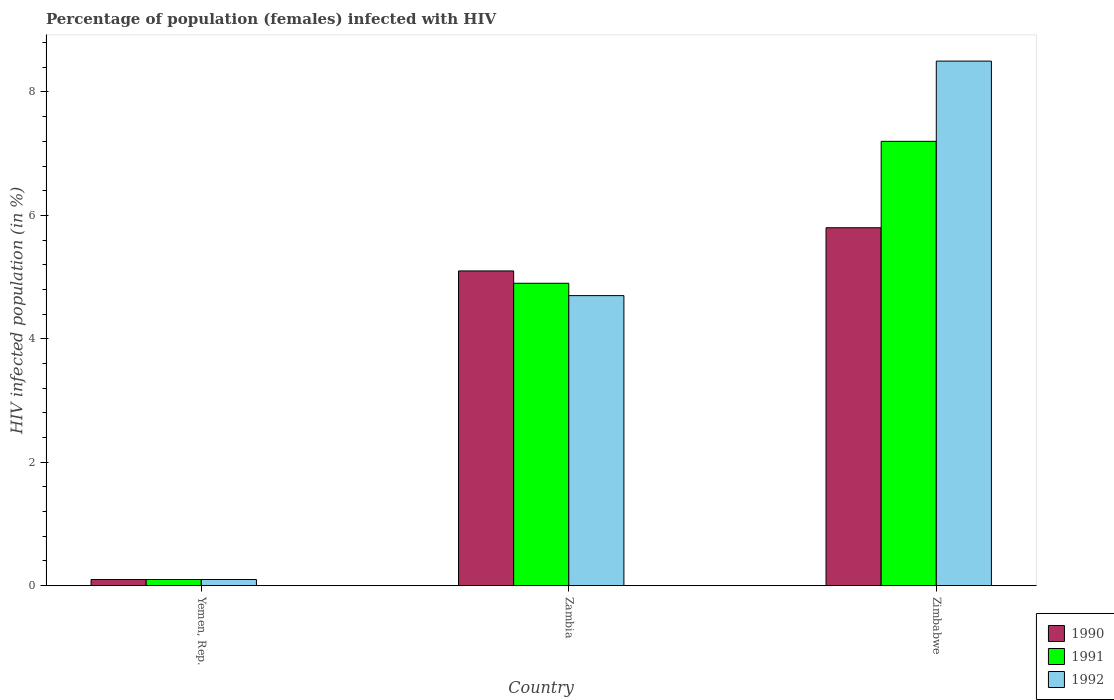How many different coloured bars are there?
Offer a terse response. 3. Are the number of bars on each tick of the X-axis equal?
Your answer should be compact. Yes. What is the label of the 1st group of bars from the left?
Your answer should be compact. Yemen, Rep. In how many cases, is the number of bars for a given country not equal to the number of legend labels?
Offer a terse response. 0. In which country was the percentage of HIV infected female population in 1990 maximum?
Make the answer very short. Zimbabwe. In which country was the percentage of HIV infected female population in 1992 minimum?
Offer a very short reply. Yemen, Rep. What is the difference between the percentage of HIV infected female population in 1991 in Zambia and the percentage of HIV infected female population in 1990 in Yemen, Rep.?
Your answer should be compact. 4.8. What is the average percentage of HIV infected female population in 1990 per country?
Your answer should be very brief. 3.67. What is the difference between the percentage of HIV infected female population of/in 1991 and percentage of HIV infected female population of/in 1990 in Zimbabwe?
Your answer should be very brief. 1.4. What is the ratio of the percentage of HIV infected female population in 1992 in Yemen, Rep. to that in Zimbabwe?
Make the answer very short. 0.01. What is the difference between the highest and the second highest percentage of HIV infected female population in 1991?
Your response must be concise. -4.8. What is the difference between the highest and the lowest percentage of HIV infected female population in 1991?
Your answer should be very brief. 7.1. In how many countries, is the percentage of HIV infected female population in 1992 greater than the average percentage of HIV infected female population in 1992 taken over all countries?
Your response must be concise. 2. Is the sum of the percentage of HIV infected female population in 1992 in Yemen, Rep. and Zimbabwe greater than the maximum percentage of HIV infected female population in 1990 across all countries?
Offer a terse response. Yes. What does the 1st bar from the right in Yemen, Rep. represents?
Provide a succinct answer. 1992. How many bars are there?
Offer a terse response. 9. Are all the bars in the graph horizontal?
Your answer should be very brief. No. How many countries are there in the graph?
Your answer should be very brief. 3. What is the difference between two consecutive major ticks on the Y-axis?
Provide a short and direct response. 2. Does the graph contain any zero values?
Your answer should be very brief. No. Where does the legend appear in the graph?
Make the answer very short. Bottom right. How many legend labels are there?
Provide a short and direct response. 3. What is the title of the graph?
Ensure brevity in your answer.  Percentage of population (females) infected with HIV. Does "1960" appear as one of the legend labels in the graph?
Provide a short and direct response. No. What is the label or title of the Y-axis?
Ensure brevity in your answer.  HIV infected population (in %). What is the HIV infected population (in %) of 1992 in Yemen, Rep.?
Make the answer very short. 0.1. What is the HIV infected population (in %) of 1991 in Zambia?
Provide a succinct answer. 4.9. What is the HIV infected population (in %) in 1992 in Zambia?
Give a very brief answer. 4.7. What is the HIV infected population (in %) in 1991 in Zimbabwe?
Give a very brief answer. 7.2. What is the HIV infected population (in %) of 1992 in Zimbabwe?
Give a very brief answer. 8.5. Across all countries, what is the maximum HIV infected population (in %) in 1990?
Provide a succinct answer. 5.8. What is the total HIV infected population (in %) in 1990 in the graph?
Your answer should be very brief. 11. What is the total HIV infected population (in %) in 1992 in the graph?
Offer a very short reply. 13.3. What is the difference between the HIV infected population (in %) of 1990 in Yemen, Rep. and that in Zambia?
Keep it short and to the point. -5. What is the difference between the HIV infected population (in %) in 1992 in Yemen, Rep. and that in Zambia?
Your answer should be very brief. -4.6. What is the difference between the HIV infected population (in %) of 1991 in Yemen, Rep. and that in Zimbabwe?
Offer a terse response. -7.1. What is the difference between the HIV infected population (in %) of 1991 in Zambia and that in Zimbabwe?
Give a very brief answer. -2.3. What is the difference between the HIV infected population (in %) of 1992 in Zambia and that in Zimbabwe?
Provide a short and direct response. -3.8. What is the difference between the HIV infected population (in %) of 1990 in Yemen, Rep. and the HIV infected population (in %) of 1992 in Zambia?
Offer a terse response. -4.6. What is the difference between the HIV infected population (in %) of 1991 in Yemen, Rep. and the HIV infected population (in %) of 1992 in Zambia?
Keep it short and to the point. -4.6. What is the difference between the HIV infected population (in %) in 1990 in Yemen, Rep. and the HIV infected population (in %) in 1991 in Zimbabwe?
Provide a short and direct response. -7.1. What is the difference between the HIV infected population (in %) of 1990 in Yemen, Rep. and the HIV infected population (in %) of 1992 in Zimbabwe?
Provide a short and direct response. -8.4. What is the difference between the HIV infected population (in %) in 1990 in Zambia and the HIV infected population (in %) in 1991 in Zimbabwe?
Your answer should be compact. -2.1. What is the difference between the HIV infected population (in %) of 1991 in Zambia and the HIV infected population (in %) of 1992 in Zimbabwe?
Your answer should be very brief. -3.6. What is the average HIV infected population (in %) of 1990 per country?
Your answer should be compact. 3.67. What is the average HIV infected population (in %) of 1991 per country?
Keep it short and to the point. 4.07. What is the average HIV infected population (in %) of 1992 per country?
Provide a succinct answer. 4.43. What is the difference between the HIV infected population (in %) of 1990 and HIV infected population (in %) of 1991 in Yemen, Rep.?
Keep it short and to the point. 0. What is the difference between the HIV infected population (in %) in 1990 and HIV infected population (in %) in 1992 in Zambia?
Offer a very short reply. 0.4. What is the difference between the HIV infected population (in %) in 1991 and HIV infected population (in %) in 1992 in Zambia?
Offer a very short reply. 0.2. What is the difference between the HIV infected population (in %) in 1990 and HIV infected population (in %) in 1991 in Zimbabwe?
Offer a very short reply. -1.4. What is the difference between the HIV infected population (in %) in 1990 and HIV infected population (in %) in 1992 in Zimbabwe?
Provide a short and direct response. -2.7. What is the ratio of the HIV infected population (in %) in 1990 in Yemen, Rep. to that in Zambia?
Your answer should be very brief. 0.02. What is the ratio of the HIV infected population (in %) in 1991 in Yemen, Rep. to that in Zambia?
Your answer should be compact. 0.02. What is the ratio of the HIV infected population (in %) in 1992 in Yemen, Rep. to that in Zambia?
Keep it short and to the point. 0.02. What is the ratio of the HIV infected population (in %) of 1990 in Yemen, Rep. to that in Zimbabwe?
Provide a succinct answer. 0.02. What is the ratio of the HIV infected population (in %) in 1991 in Yemen, Rep. to that in Zimbabwe?
Provide a short and direct response. 0.01. What is the ratio of the HIV infected population (in %) in 1992 in Yemen, Rep. to that in Zimbabwe?
Your answer should be compact. 0.01. What is the ratio of the HIV infected population (in %) of 1990 in Zambia to that in Zimbabwe?
Your answer should be very brief. 0.88. What is the ratio of the HIV infected population (in %) of 1991 in Zambia to that in Zimbabwe?
Offer a very short reply. 0.68. What is the ratio of the HIV infected population (in %) in 1992 in Zambia to that in Zimbabwe?
Make the answer very short. 0.55. What is the difference between the highest and the second highest HIV infected population (in %) in 1990?
Your answer should be very brief. 0.7. What is the difference between the highest and the lowest HIV infected population (in %) of 1990?
Your answer should be very brief. 5.7. What is the difference between the highest and the lowest HIV infected population (in %) in 1992?
Give a very brief answer. 8.4. 